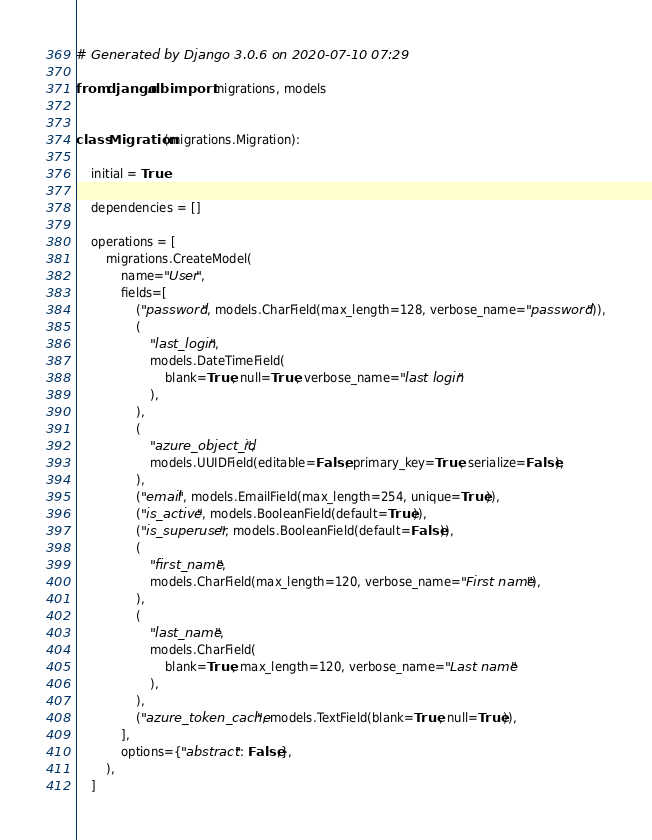Convert code to text. <code><loc_0><loc_0><loc_500><loc_500><_Python_># Generated by Django 3.0.6 on 2020-07-10 07:29

from django.db import migrations, models


class Migration(migrations.Migration):

    initial = True

    dependencies = []

    operations = [
        migrations.CreateModel(
            name="User",
            fields=[
                ("password", models.CharField(max_length=128, verbose_name="password")),
                (
                    "last_login",
                    models.DateTimeField(
                        blank=True, null=True, verbose_name="last login"
                    ),
                ),
                (
                    "azure_object_id",
                    models.UUIDField(editable=False, primary_key=True, serialize=False),
                ),
                ("email", models.EmailField(max_length=254, unique=True)),
                ("is_active", models.BooleanField(default=True)),
                ("is_superuser", models.BooleanField(default=False)),
                (
                    "first_name",
                    models.CharField(max_length=120, verbose_name="First name"),
                ),
                (
                    "last_name",
                    models.CharField(
                        blank=True, max_length=120, verbose_name="Last name"
                    ),
                ),
                ("azure_token_cache", models.TextField(blank=True, null=True)),
            ],
            options={"abstract": False,},
        ),
    ]
</code> 